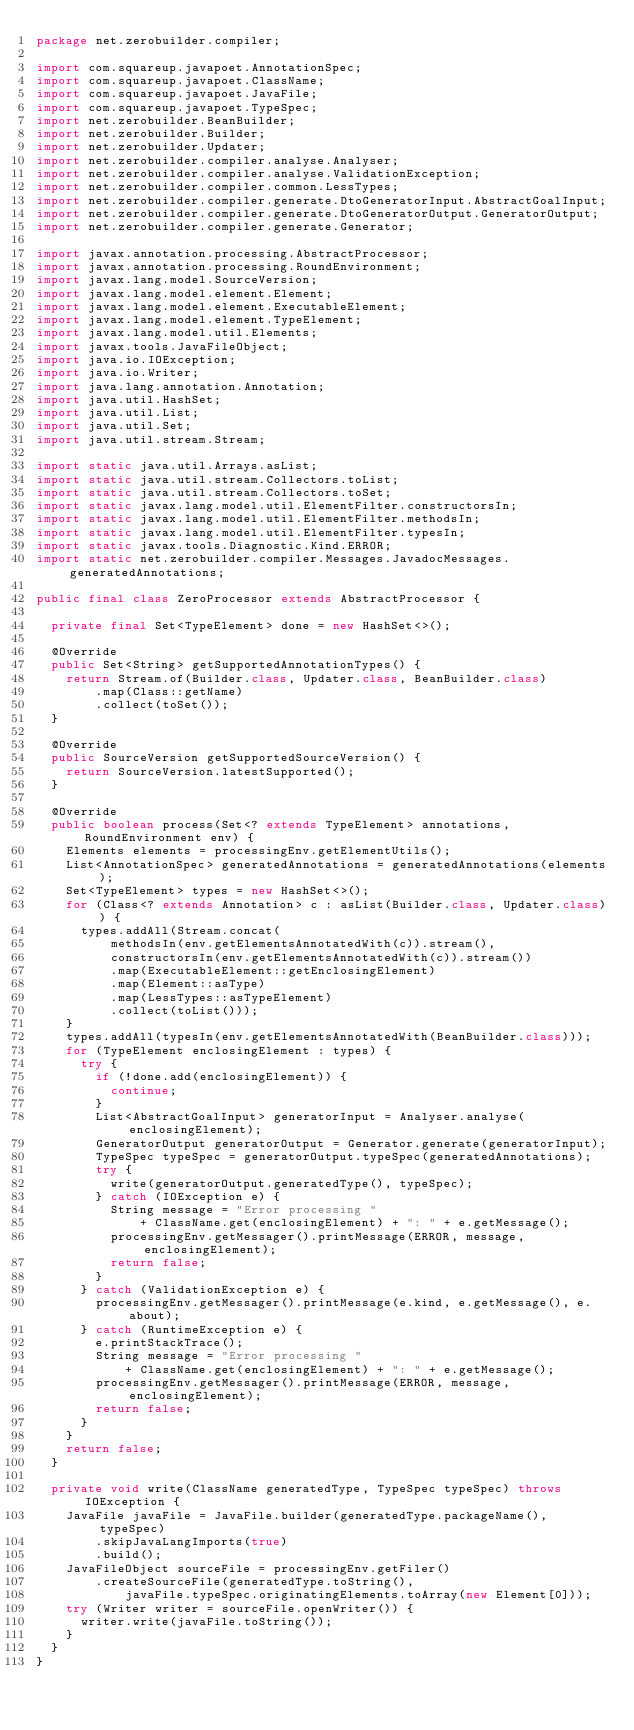Convert code to text. <code><loc_0><loc_0><loc_500><loc_500><_Java_>package net.zerobuilder.compiler;

import com.squareup.javapoet.AnnotationSpec;
import com.squareup.javapoet.ClassName;
import com.squareup.javapoet.JavaFile;
import com.squareup.javapoet.TypeSpec;
import net.zerobuilder.BeanBuilder;
import net.zerobuilder.Builder;
import net.zerobuilder.Updater;
import net.zerobuilder.compiler.analyse.Analyser;
import net.zerobuilder.compiler.analyse.ValidationException;
import net.zerobuilder.compiler.common.LessTypes;
import net.zerobuilder.compiler.generate.DtoGeneratorInput.AbstractGoalInput;
import net.zerobuilder.compiler.generate.DtoGeneratorOutput.GeneratorOutput;
import net.zerobuilder.compiler.generate.Generator;

import javax.annotation.processing.AbstractProcessor;
import javax.annotation.processing.RoundEnvironment;
import javax.lang.model.SourceVersion;
import javax.lang.model.element.Element;
import javax.lang.model.element.ExecutableElement;
import javax.lang.model.element.TypeElement;
import javax.lang.model.util.Elements;
import javax.tools.JavaFileObject;
import java.io.IOException;
import java.io.Writer;
import java.lang.annotation.Annotation;
import java.util.HashSet;
import java.util.List;
import java.util.Set;
import java.util.stream.Stream;

import static java.util.Arrays.asList;
import static java.util.stream.Collectors.toList;
import static java.util.stream.Collectors.toSet;
import static javax.lang.model.util.ElementFilter.constructorsIn;
import static javax.lang.model.util.ElementFilter.methodsIn;
import static javax.lang.model.util.ElementFilter.typesIn;
import static javax.tools.Diagnostic.Kind.ERROR;
import static net.zerobuilder.compiler.Messages.JavadocMessages.generatedAnnotations;

public final class ZeroProcessor extends AbstractProcessor {

  private final Set<TypeElement> done = new HashSet<>();

  @Override
  public Set<String> getSupportedAnnotationTypes() {
    return Stream.of(Builder.class, Updater.class, BeanBuilder.class)
        .map(Class::getName)
        .collect(toSet());
  }

  @Override
  public SourceVersion getSupportedSourceVersion() {
    return SourceVersion.latestSupported();
  }

  @Override
  public boolean process(Set<? extends TypeElement> annotations, RoundEnvironment env) {
    Elements elements = processingEnv.getElementUtils();
    List<AnnotationSpec> generatedAnnotations = generatedAnnotations(elements);
    Set<TypeElement> types = new HashSet<>();
    for (Class<? extends Annotation> c : asList(Builder.class, Updater.class)) {
      types.addAll(Stream.concat(
          methodsIn(env.getElementsAnnotatedWith(c)).stream(),
          constructorsIn(env.getElementsAnnotatedWith(c)).stream())
          .map(ExecutableElement::getEnclosingElement)
          .map(Element::asType)
          .map(LessTypes::asTypeElement)
          .collect(toList()));
    }
    types.addAll(typesIn(env.getElementsAnnotatedWith(BeanBuilder.class)));
    for (TypeElement enclosingElement : types) {
      try {
        if (!done.add(enclosingElement)) {
          continue;
        }
        List<AbstractGoalInput> generatorInput = Analyser.analyse(enclosingElement);
        GeneratorOutput generatorOutput = Generator.generate(generatorInput);
        TypeSpec typeSpec = generatorOutput.typeSpec(generatedAnnotations);
        try {
          write(generatorOutput.generatedType(), typeSpec);
        } catch (IOException e) {
          String message = "Error processing "
              + ClassName.get(enclosingElement) + ": " + e.getMessage();
          processingEnv.getMessager().printMessage(ERROR, message, enclosingElement);
          return false;
        }
      } catch (ValidationException e) {
        processingEnv.getMessager().printMessage(e.kind, e.getMessage(), e.about);
      } catch (RuntimeException e) {
        e.printStackTrace();
        String message = "Error processing "
            + ClassName.get(enclosingElement) + ": " + e.getMessage();
        processingEnv.getMessager().printMessage(ERROR, message, enclosingElement);
        return false;
      }
    }
    return false;
  }

  private void write(ClassName generatedType, TypeSpec typeSpec) throws IOException {
    JavaFile javaFile = JavaFile.builder(generatedType.packageName(), typeSpec)
        .skipJavaLangImports(true)
        .build();
    JavaFileObject sourceFile = processingEnv.getFiler()
        .createSourceFile(generatedType.toString(),
            javaFile.typeSpec.originatingElements.toArray(new Element[0]));
    try (Writer writer = sourceFile.openWriter()) {
      writer.write(javaFile.toString());
    }
  }
}</code> 